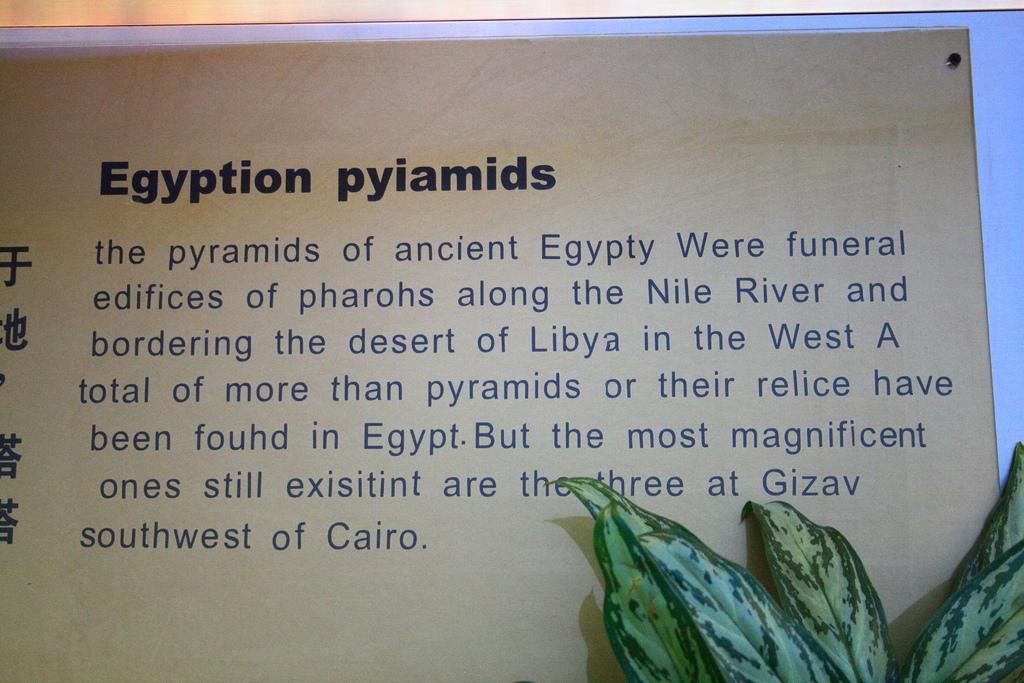What is the title of the paragraph?
Your answer should be very brief. Egyption pyiamids. Where do the most magnificent ones still exist?
Keep it short and to the point. Gizav, southwest of cairo. 